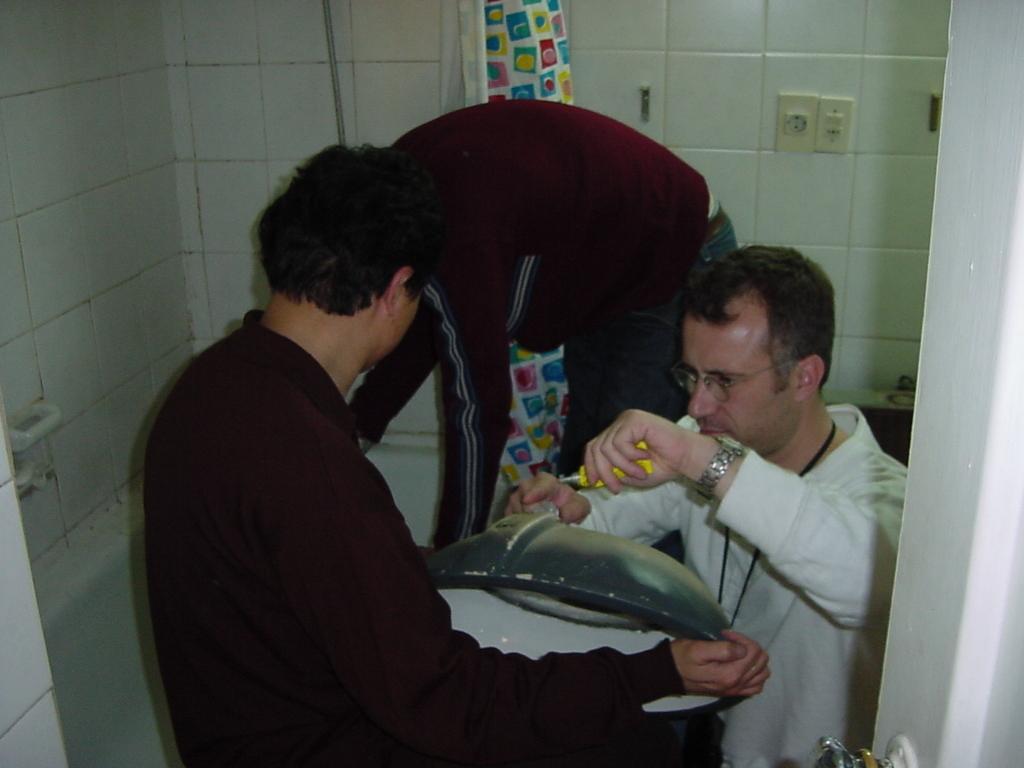Could you give a brief overview of what you see in this image? In this image there is a man on the right side who is fixing the screw to the bowl which is in front of him. On the left side there is another man who is holding the bowl. In the background there is a man who is in bending position. Behind him there is a wall. 